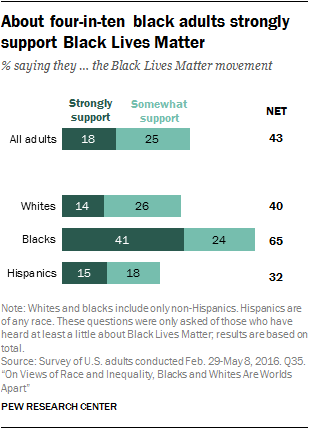Outline some significant characteristics in this image. The average net opinion and the smallest net opinion were added. The number of colors of bars displayed is between 2 and... 